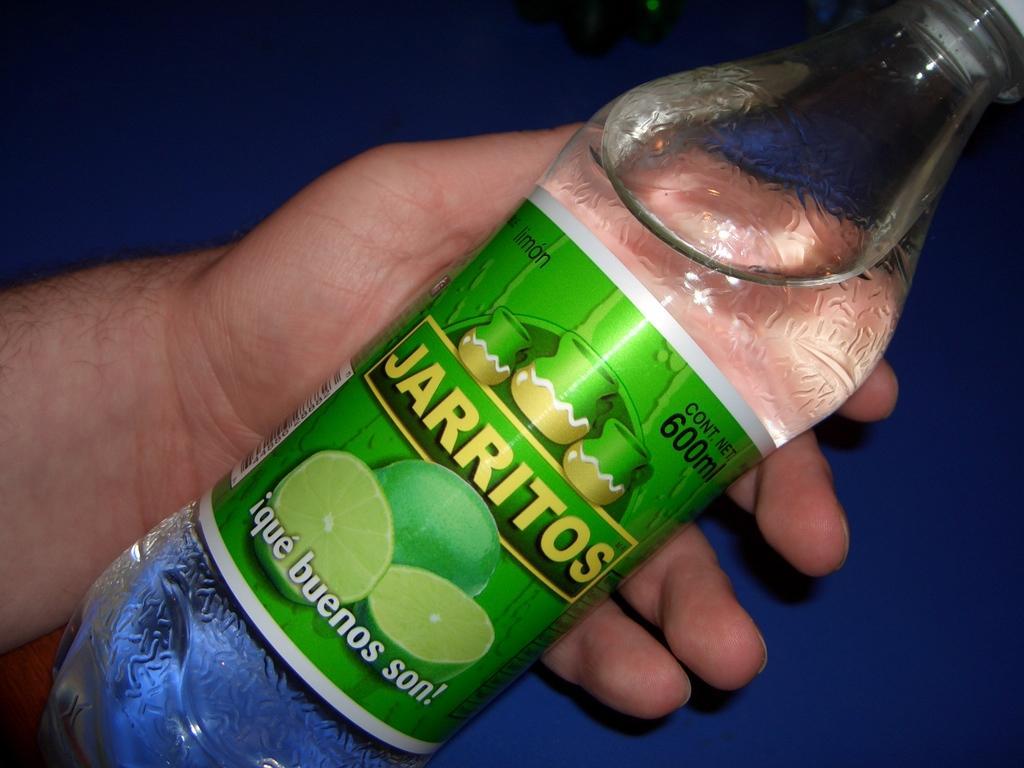Could you give a brief overview of what you see in this image? In this image there is a person holding a water bottle and in water bottle there is a label and a lid. 